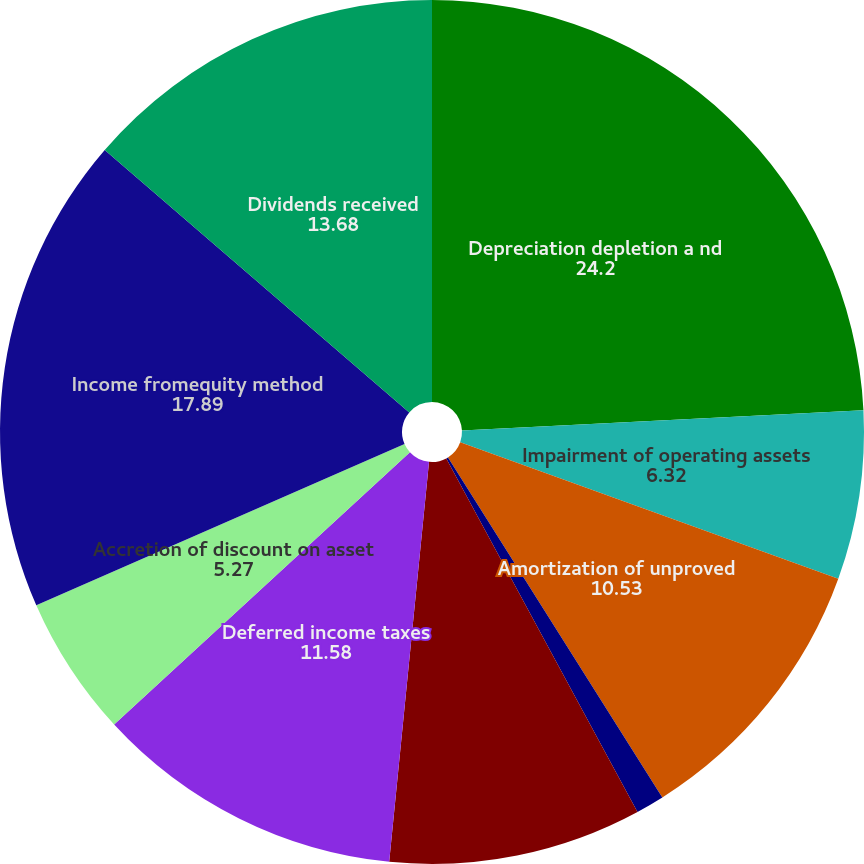Convert chart to OTSL. <chart><loc_0><loc_0><loc_500><loc_500><pie_chart><fcel>Depreciation depletion a nd<fcel>Impairment of operating assets<fcel>Amortization of unproved<fcel>Stock-based compensation<fcel>Gain on sale of assets<fcel>Deferred income taxes<fcel>Accretion of discount on asset<fcel>Income fromequity method<fcel>Dividends received<fcel>Loss on derivative instruments<nl><fcel>24.2%<fcel>6.32%<fcel>10.53%<fcel>1.06%<fcel>9.47%<fcel>11.58%<fcel>5.27%<fcel>17.89%<fcel>13.68%<fcel>0.0%<nl></chart> 